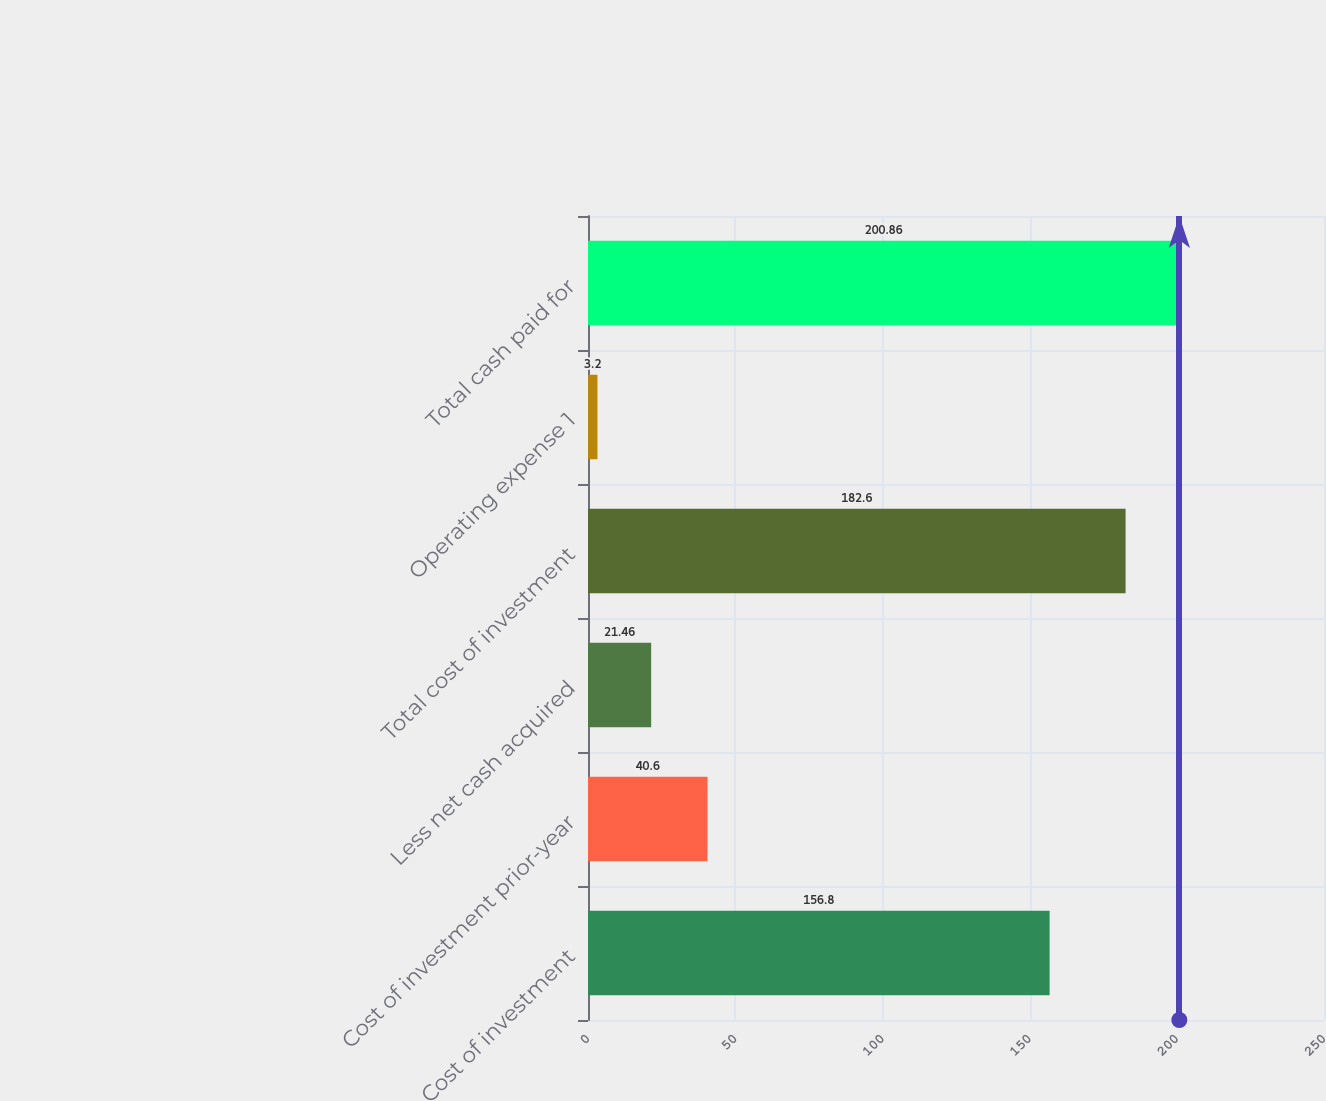Convert chart to OTSL. <chart><loc_0><loc_0><loc_500><loc_500><bar_chart><fcel>Cost of investment<fcel>Cost of investment prior-year<fcel>Less net cash acquired<fcel>Total cost of investment<fcel>Operating expense 1<fcel>Total cash paid for<nl><fcel>156.8<fcel>40.6<fcel>21.46<fcel>182.6<fcel>3.2<fcel>200.86<nl></chart> 